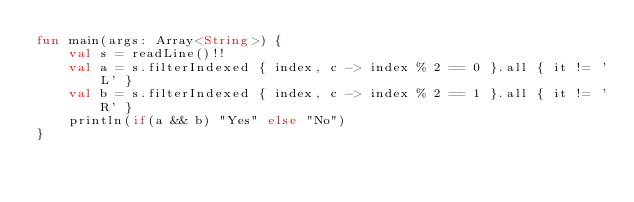Convert code to text. <code><loc_0><loc_0><loc_500><loc_500><_Kotlin_>fun main(args: Array<String>) {
    val s = readLine()!!
    val a = s.filterIndexed { index, c -> index % 2 == 0 }.all { it != 'L' }
    val b = s.filterIndexed { index, c -> index % 2 == 1 }.all { it != 'R' }
    println(if(a && b) "Yes" else "No")
}</code> 